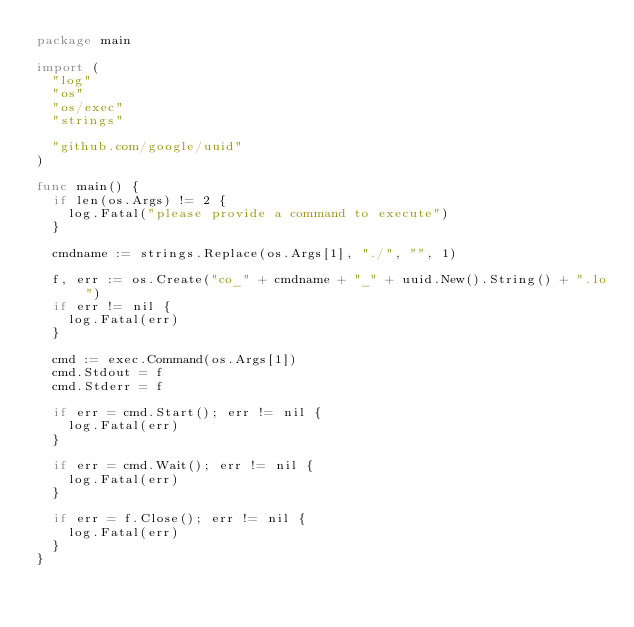<code> <loc_0><loc_0><loc_500><loc_500><_Go_>package main

import (
	"log"
	"os"
	"os/exec"
	"strings"

	"github.com/google/uuid"
)

func main() {
	if len(os.Args) != 2 {
		log.Fatal("please provide a command to execute")
	}

	cmdname := strings.Replace(os.Args[1], "./", "", 1)

	f, err := os.Create("co_" + cmdname + "_" + uuid.New().String() + ".lo")
	if err != nil {
		log.Fatal(err)
	}

	cmd := exec.Command(os.Args[1])
	cmd.Stdout = f
	cmd.Stderr = f

	if err = cmd.Start(); err != nil {
		log.Fatal(err)
	}

	if err = cmd.Wait(); err != nil {
		log.Fatal(err)
	}

	if err = f.Close(); err != nil {
		log.Fatal(err)
	}
}
</code> 